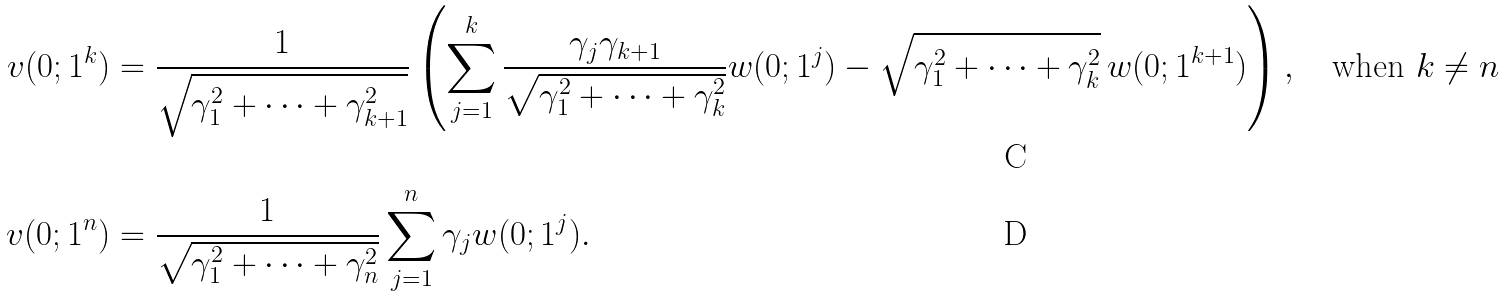<formula> <loc_0><loc_0><loc_500><loc_500>v ( 0 ; 1 ^ { k } ) & = \frac { 1 } { \sqrt { \gamma _ { 1 } ^ { 2 } + \cdots + \gamma _ { k + 1 } ^ { 2 } } } \left ( \sum _ { j = 1 } ^ { k } \frac { \gamma _ { j } \gamma _ { k + 1 } } { \sqrt { \gamma _ { 1 } ^ { 2 } + \cdots + \gamma _ { k } ^ { 2 } } } w ( 0 ; 1 ^ { j } ) - \sqrt { \gamma _ { 1 } ^ { 2 } + \cdots + \gamma _ { k } ^ { 2 } } \, w ( 0 ; 1 ^ { k + 1 } ) \right ) , \quad \text {when} \ k \neq n \\ v ( 0 ; 1 ^ { n } ) & = \frac { 1 } { \sqrt { \gamma _ { 1 } ^ { 2 } + \cdots + \gamma _ { n } ^ { 2 } } } \sum _ { j = 1 } ^ { n } \gamma _ { j } w ( 0 ; 1 ^ { j } ) .</formula> 